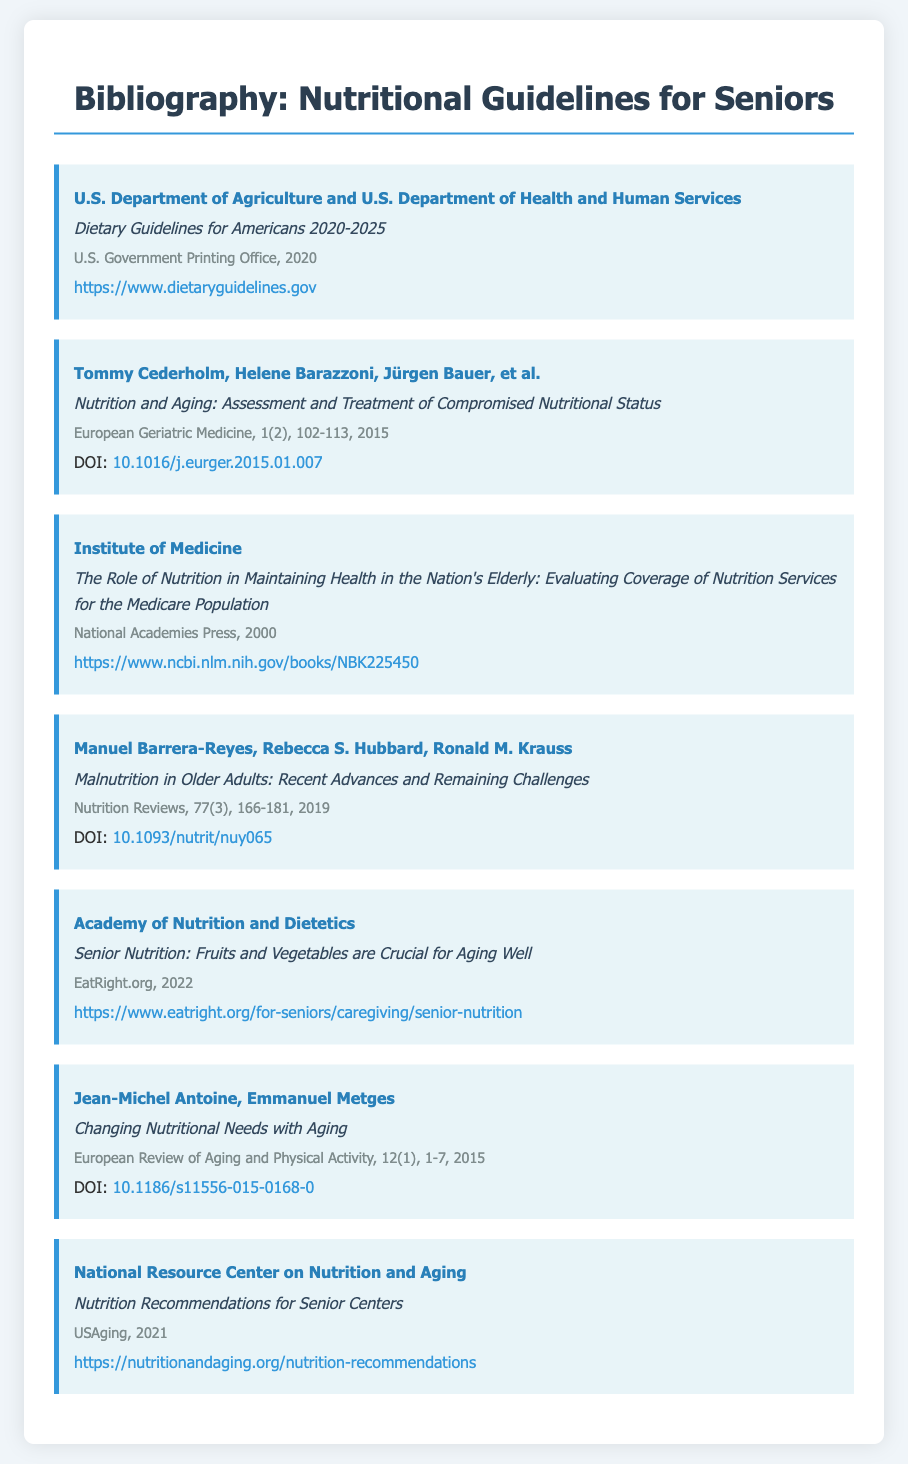what is the title of the USDA guidelines? The title of the USDA guidelines is listed as "Dietary Guidelines for Americans 2020-2025."
Answer: Dietary Guidelines for Americans 2020-2025 who are the authors of the article on nutrition and aging? The authors of the article on nutrition and aging are listed as Tommy Cederholm, Helene Barazzoni, Jürgen Bauer, et al.
Answer: Tommy Cederholm, Helene Barazzoni, Jürgen Bauer, et al when was the "Role of Nutrition in Maintaining Health in the Nation's Elderly" published? The publication year of "The Role of Nutrition in Maintaining Health in the Nation's Elderly" is 2000.
Answer: 2000 what is the DOI of the article "Malnutrition in Older Adults"? The DOI of the article "Malnutrition in Older Adults" is provided as "10.1093/nutrit/nuy065."
Answer: 10.1093/nutrit/nuy065 where can the information about senior nutrition be found according to the Academy of Nutrition and Dietetics? The information is available on the EatRight.org website.
Answer: EatRight.org what type of publication is the source by the National Resource Center on Nutrition and Aging? The source by the National Resource Center on Nutrition and Aging is identified as a report.
Answer: report which journal published "Changing Nutritional Needs with Aging"? The journal that published "Changing Nutritional Needs with Aging" is called "European Review of Aging and Physical Activity."
Answer: European Review of Aging and Physical Activity what is the publication year of the document titled "Nutrition Recommendations for Senior Centers"? The publication year for "Nutrition Recommendations for Senior Centers" is 2021.
Answer: 2021 